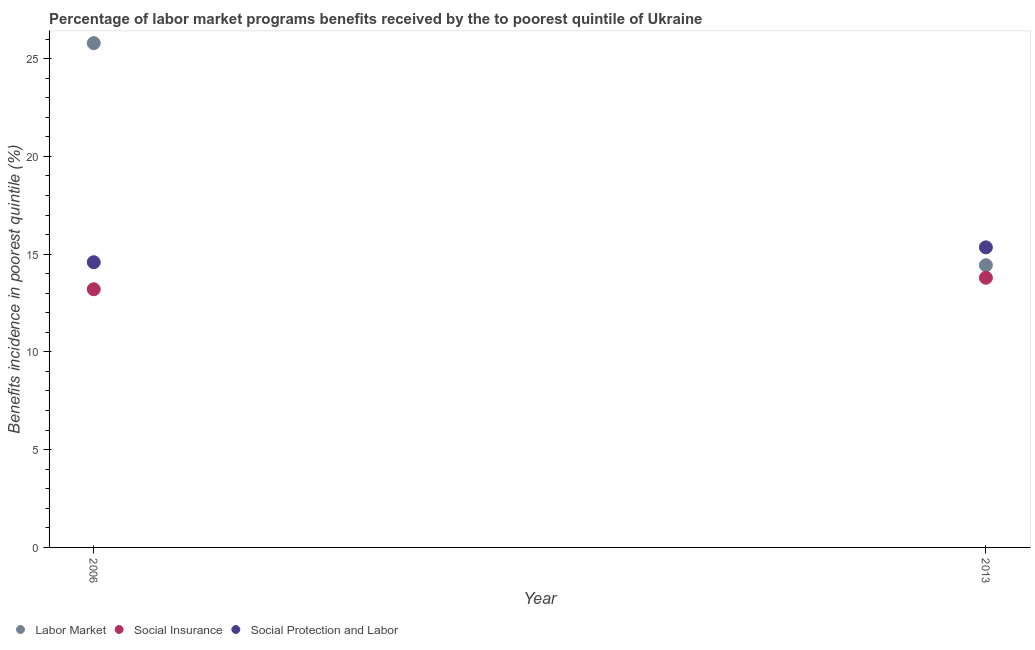What is the percentage of benefits received due to social insurance programs in 2006?
Provide a short and direct response. 13.2. Across all years, what is the maximum percentage of benefits received due to social protection programs?
Offer a terse response. 15.35. Across all years, what is the minimum percentage of benefits received due to social insurance programs?
Your response must be concise. 13.2. What is the total percentage of benefits received due to social protection programs in the graph?
Your answer should be very brief. 29.93. What is the difference between the percentage of benefits received due to social insurance programs in 2006 and that in 2013?
Your response must be concise. -0.59. What is the difference between the percentage of benefits received due to social protection programs in 2006 and the percentage of benefits received due to labor market programs in 2013?
Your answer should be very brief. 0.15. What is the average percentage of benefits received due to social protection programs per year?
Provide a short and direct response. 14.97. In the year 2006, what is the difference between the percentage of benefits received due to social insurance programs and percentage of benefits received due to labor market programs?
Ensure brevity in your answer.  -12.59. In how many years, is the percentage of benefits received due to labor market programs greater than 21 %?
Provide a succinct answer. 1. What is the ratio of the percentage of benefits received due to social protection programs in 2006 to that in 2013?
Your answer should be compact. 0.95. Is it the case that in every year, the sum of the percentage of benefits received due to labor market programs and percentage of benefits received due to social insurance programs is greater than the percentage of benefits received due to social protection programs?
Offer a terse response. Yes. Is the percentage of benefits received due to social protection programs strictly less than the percentage of benefits received due to social insurance programs over the years?
Make the answer very short. No. How many dotlines are there?
Give a very brief answer. 3. Are the values on the major ticks of Y-axis written in scientific E-notation?
Ensure brevity in your answer.  No. Does the graph contain any zero values?
Keep it short and to the point. No. Where does the legend appear in the graph?
Your response must be concise. Bottom left. How many legend labels are there?
Offer a very short reply. 3. How are the legend labels stacked?
Ensure brevity in your answer.  Horizontal. What is the title of the graph?
Offer a very short reply. Percentage of labor market programs benefits received by the to poorest quintile of Ukraine. Does "Tertiary" appear as one of the legend labels in the graph?
Provide a succinct answer. No. What is the label or title of the X-axis?
Offer a very short reply. Year. What is the label or title of the Y-axis?
Offer a terse response. Benefits incidence in poorest quintile (%). What is the Benefits incidence in poorest quintile (%) of Labor Market in 2006?
Offer a very short reply. 25.79. What is the Benefits incidence in poorest quintile (%) in Social Insurance in 2006?
Your answer should be compact. 13.2. What is the Benefits incidence in poorest quintile (%) in Social Protection and Labor in 2006?
Keep it short and to the point. 14.59. What is the Benefits incidence in poorest quintile (%) in Labor Market in 2013?
Your answer should be very brief. 14.43. What is the Benefits incidence in poorest quintile (%) of Social Insurance in 2013?
Offer a terse response. 13.79. What is the Benefits incidence in poorest quintile (%) in Social Protection and Labor in 2013?
Provide a succinct answer. 15.35. Across all years, what is the maximum Benefits incidence in poorest quintile (%) in Labor Market?
Provide a short and direct response. 25.79. Across all years, what is the maximum Benefits incidence in poorest quintile (%) of Social Insurance?
Your response must be concise. 13.79. Across all years, what is the maximum Benefits incidence in poorest quintile (%) in Social Protection and Labor?
Your answer should be compact. 15.35. Across all years, what is the minimum Benefits incidence in poorest quintile (%) in Labor Market?
Your answer should be compact. 14.43. Across all years, what is the minimum Benefits incidence in poorest quintile (%) in Social Insurance?
Your answer should be very brief. 13.2. Across all years, what is the minimum Benefits incidence in poorest quintile (%) in Social Protection and Labor?
Provide a succinct answer. 14.59. What is the total Benefits incidence in poorest quintile (%) in Labor Market in the graph?
Offer a very short reply. 40.22. What is the total Benefits incidence in poorest quintile (%) in Social Insurance in the graph?
Offer a terse response. 26.99. What is the total Benefits incidence in poorest quintile (%) in Social Protection and Labor in the graph?
Your response must be concise. 29.93. What is the difference between the Benefits incidence in poorest quintile (%) in Labor Market in 2006 and that in 2013?
Make the answer very short. 11.36. What is the difference between the Benefits incidence in poorest quintile (%) in Social Insurance in 2006 and that in 2013?
Make the answer very short. -0.59. What is the difference between the Benefits incidence in poorest quintile (%) of Social Protection and Labor in 2006 and that in 2013?
Provide a succinct answer. -0.76. What is the difference between the Benefits incidence in poorest quintile (%) of Labor Market in 2006 and the Benefits incidence in poorest quintile (%) of Social Insurance in 2013?
Offer a terse response. 12. What is the difference between the Benefits incidence in poorest quintile (%) of Labor Market in 2006 and the Benefits incidence in poorest quintile (%) of Social Protection and Labor in 2013?
Provide a succinct answer. 10.44. What is the difference between the Benefits incidence in poorest quintile (%) of Social Insurance in 2006 and the Benefits incidence in poorest quintile (%) of Social Protection and Labor in 2013?
Your response must be concise. -2.14. What is the average Benefits incidence in poorest quintile (%) in Labor Market per year?
Your answer should be very brief. 20.11. What is the average Benefits incidence in poorest quintile (%) of Social Insurance per year?
Provide a succinct answer. 13.5. What is the average Benefits incidence in poorest quintile (%) of Social Protection and Labor per year?
Your response must be concise. 14.97. In the year 2006, what is the difference between the Benefits incidence in poorest quintile (%) in Labor Market and Benefits incidence in poorest quintile (%) in Social Insurance?
Provide a short and direct response. 12.59. In the year 2006, what is the difference between the Benefits incidence in poorest quintile (%) of Labor Market and Benefits incidence in poorest quintile (%) of Social Protection and Labor?
Make the answer very short. 11.21. In the year 2006, what is the difference between the Benefits incidence in poorest quintile (%) in Social Insurance and Benefits incidence in poorest quintile (%) in Social Protection and Labor?
Your answer should be compact. -1.38. In the year 2013, what is the difference between the Benefits incidence in poorest quintile (%) in Labor Market and Benefits incidence in poorest quintile (%) in Social Insurance?
Keep it short and to the point. 0.64. In the year 2013, what is the difference between the Benefits incidence in poorest quintile (%) in Labor Market and Benefits incidence in poorest quintile (%) in Social Protection and Labor?
Your answer should be very brief. -0.91. In the year 2013, what is the difference between the Benefits incidence in poorest quintile (%) in Social Insurance and Benefits incidence in poorest quintile (%) in Social Protection and Labor?
Make the answer very short. -1.56. What is the ratio of the Benefits incidence in poorest quintile (%) in Labor Market in 2006 to that in 2013?
Give a very brief answer. 1.79. What is the ratio of the Benefits incidence in poorest quintile (%) of Social Insurance in 2006 to that in 2013?
Your response must be concise. 0.96. What is the ratio of the Benefits incidence in poorest quintile (%) of Social Protection and Labor in 2006 to that in 2013?
Ensure brevity in your answer.  0.95. What is the difference between the highest and the second highest Benefits incidence in poorest quintile (%) in Labor Market?
Make the answer very short. 11.36. What is the difference between the highest and the second highest Benefits incidence in poorest quintile (%) in Social Insurance?
Provide a short and direct response. 0.59. What is the difference between the highest and the second highest Benefits incidence in poorest quintile (%) of Social Protection and Labor?
Keep it short and to the point. 0.76. What is the difference between the highest and the lowest Benefits incidence in poorest quintile (%) of Labor Market?
Your answer should be very brief. 11.36. What is the difference between the highest and the lowest Benefits incidence in poorest quintile (%) in Social Insurance?
Make the answer very short. 0.59. What is the difference between the highest and the lowest Benefits incidence in poorest quintile (%) in Social Protection and Labor?
Your answer should be compact. 0.76. 